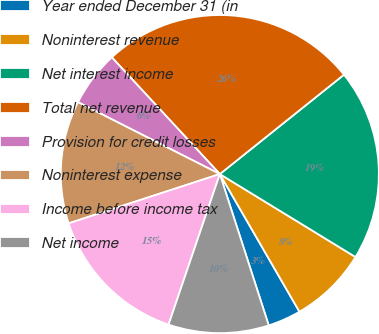<chart> <loc_0><loc_0><loc_500><loc_500><pie_chart><fcel>Year ended December 31 (in<fcel>Noninterest revenue<fcel>Net interest income<fcel>Total net revenue<fcel>Provision for credit losses<fcel>Noninterest expense<fcel>Income before income tax<fcel>Net income<nl><fcel>3.37%<fcel>7.92%<fcel>19.48%<fcel>26.14%<fcel>5.65%<fcel>12.48%<fcel>14.76%<fcel>10.2%<nl></chart> 